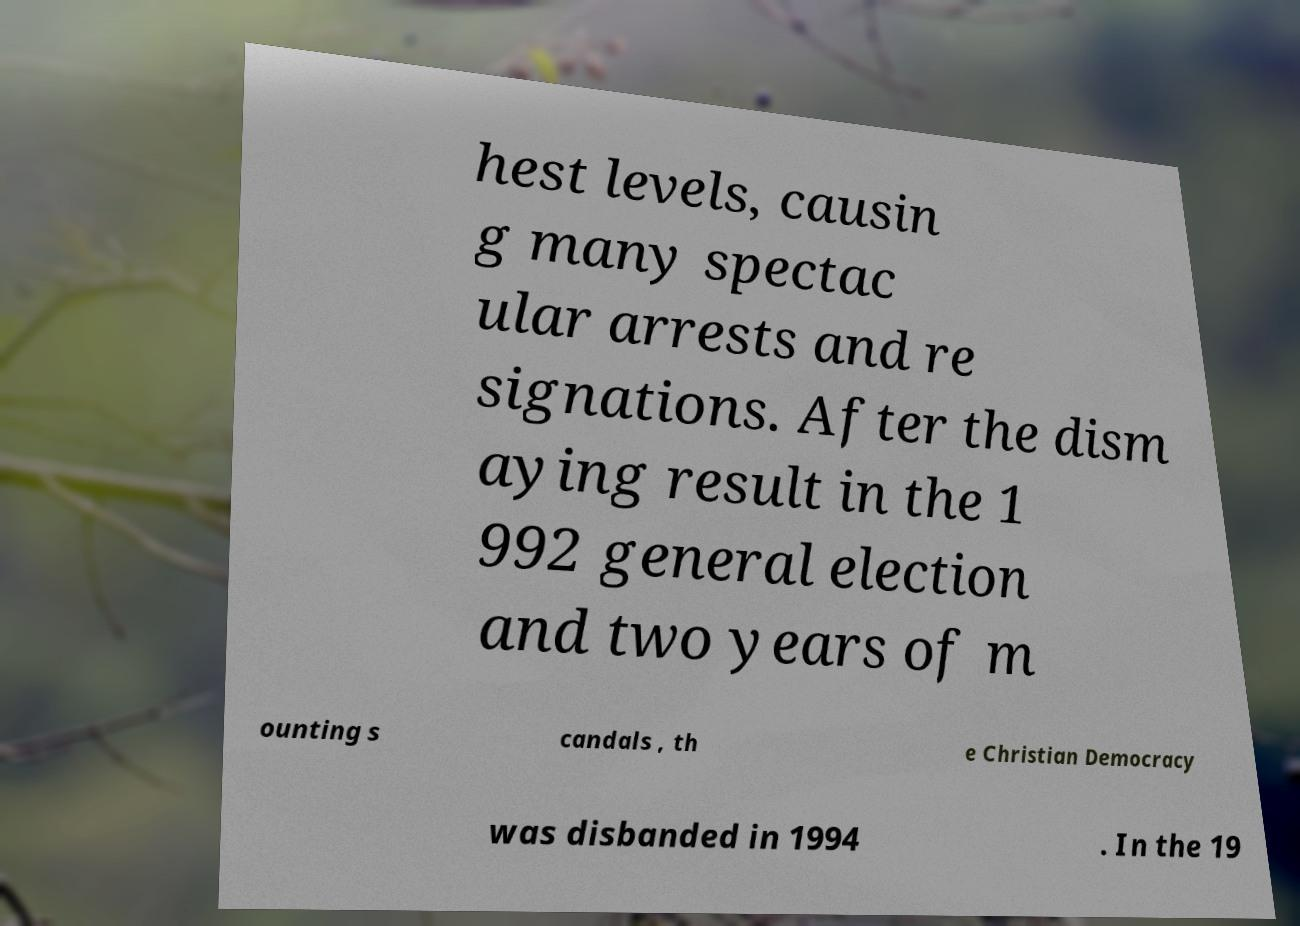I need the written content from this picture converted into text. Can you do that? hest levels, causin g many spectac ular arrests and re signations. After the dism aying result in the 1 992 general election and two years of m ounting s candals , th e Christian Democracy was disbanded in 1994 . In the 19 